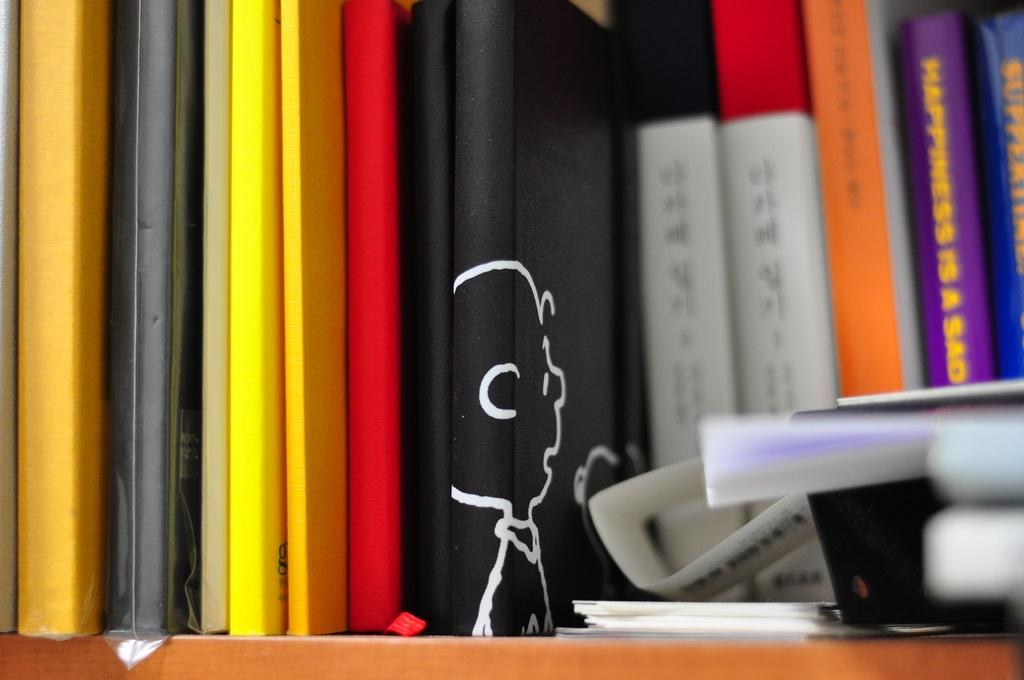<image>
Create a compact narrative representing the image presented. A shelf holding books with the obscured title one called Happiness is a Sad something. 